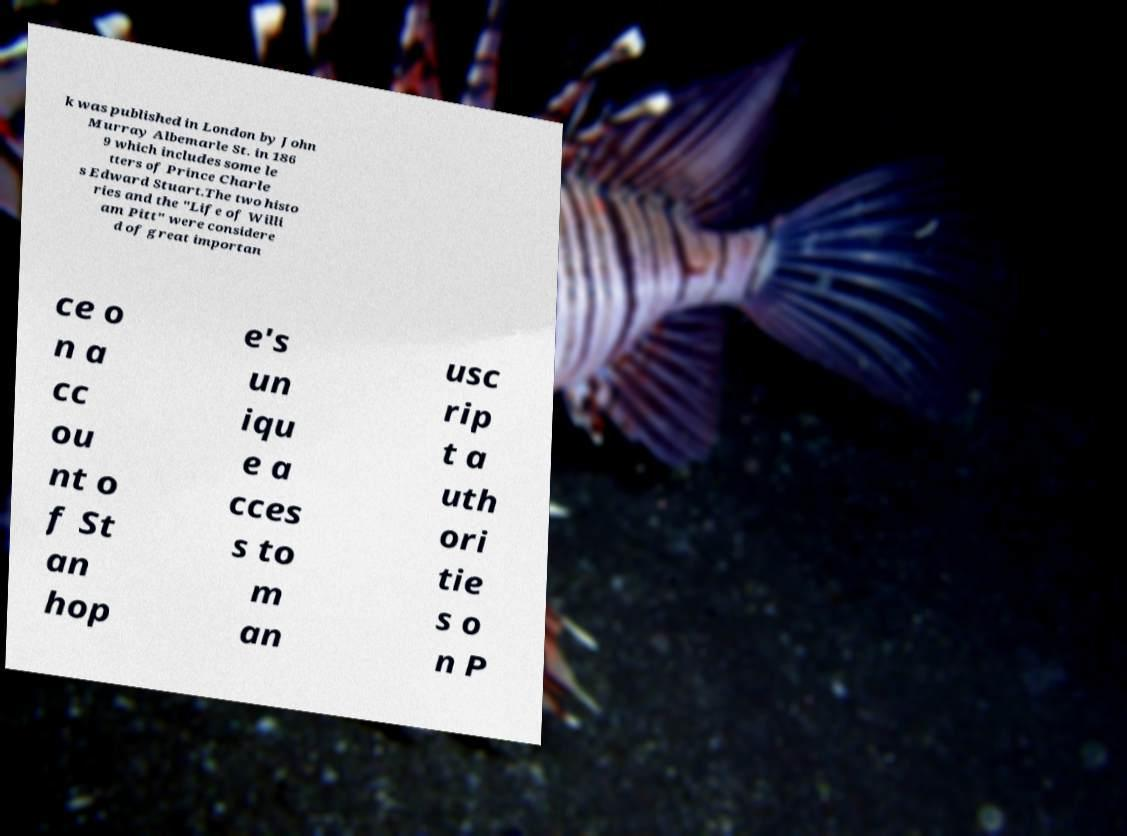What messages or text are displayed in this image? I need them in a readable, typed format. k was published in London by John Murray Albemarle St. in 186 9 which includes some le tters of Prince Charle s Edward Stuart.The two histo ries and the "Life of Willi am Pitt" were considere d of great importan ce o n a cc ou nt o f St an hop e's un iqu e a cces s to m an usc rip t a uth ori tie s o n P 